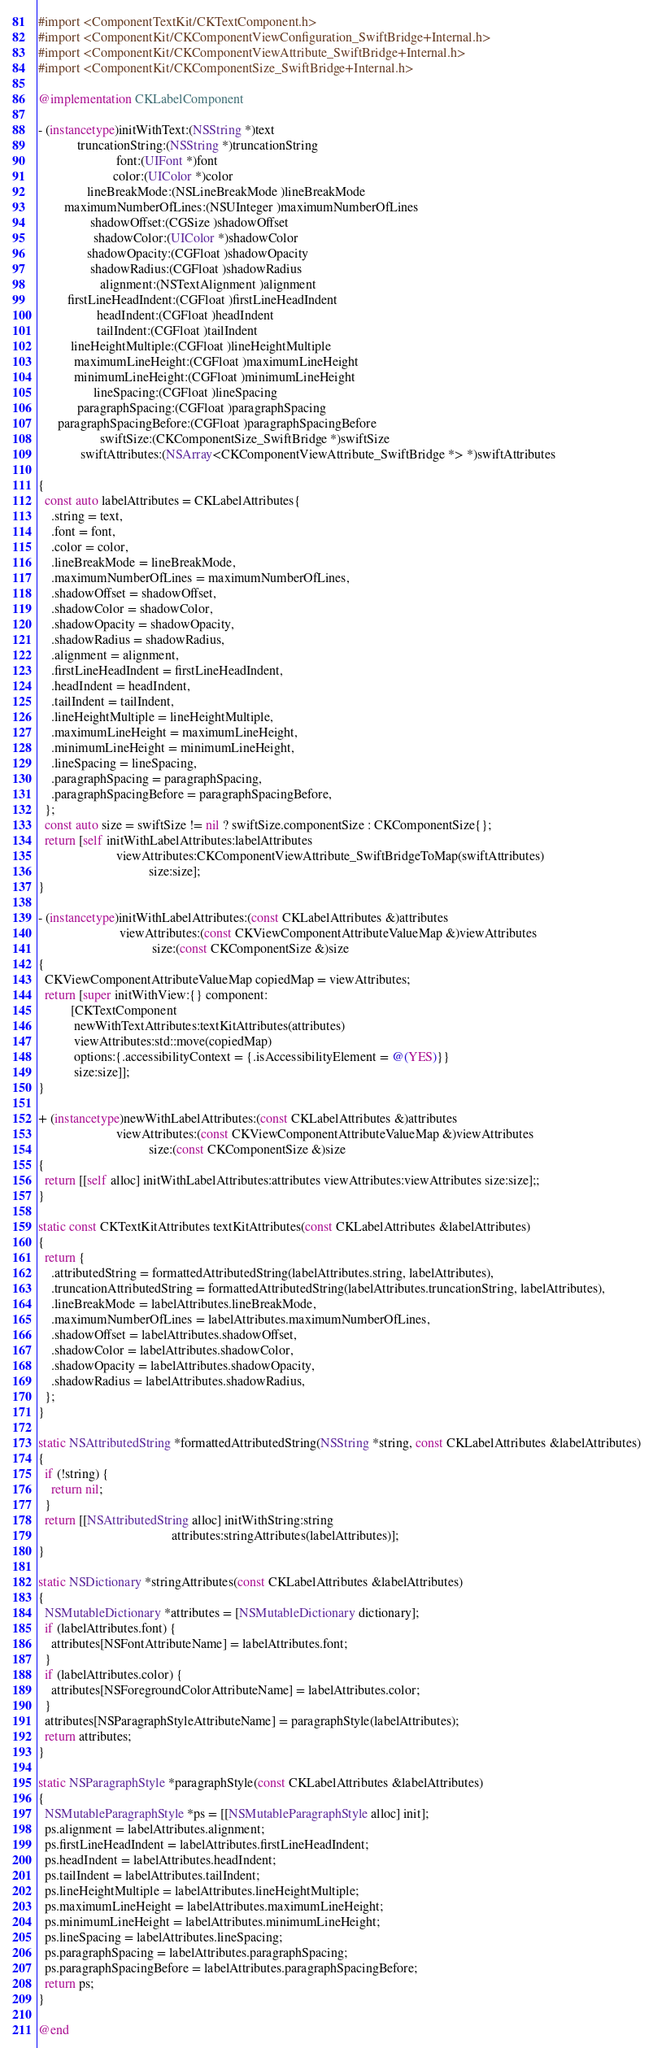Convert code to text. <code><loc_0><loc_0><loc_500><loc_500><_ObjectiveC_>#import <ComponentTextKit/CKTextComponent.h>
#import <ComponentKit/CKComponentViewConfiguration_SwiftBridge+Internal.h>
#import <ComponentKit/CKComponentViewAttribute_SwiftBridge+Internal.h>
#import <ComponentKit/CKComponentSize_SwiftBridge+Internal.h>

@implementation CKLabelComponent

- (instancetype)initWithText:(NSString *)text
            truncationString:(NSString *)truncationString
                        font:(UIFont *)font
                       color:(UIColor *)color
               lineBreakMode:(NSLineBreakMode )lineBreakMode
        maximumNumberOfLines:(NSUInteger )maximumNumberOfLines
                shadowOffset:(CGSize )shadowOffset
                 shadowColor:(UIColor *)shadowColor
               shadowOpacity:(CGFloat )shadowOpacity
                shadowRadius:(CGFloat )shadowRadius
                   alignment:(NSTextAlignment )alignment
         firstLineHeadIndent:(CGFloat )firstLineHeadIndent
                  headIndent:(CGFloat )headIndent
                  tailIndent:(CGFloat )tailIndent
          lineHeightMultiple:(CGFloat )lineHeightMultiple
           maximumLineHeight:(CGFloat )maximumLineHeight
           minimumLineHeight:(CGFloat )minimumLineHeight
                 lineSpacing:(CGFloat )lineSpacing
            paragraphSpacing:(CGFloat )paragraphSpacing
      paragraphSpacingBefore:(CGFloat )paragraphSpacingBefore
                   swiftSize:(CKComponentSize_SwiftBridge *)swiftSize
             swiftAttributes:(NSArray<CKComponentViewAttribute_SwiftBridge *> *)swiftAttributes

{
  const auto labelAttributes = CKLabelAttributes{
    .string = text,
    .font = font,
    .color = color,
    .lineBreakMode = lineBreakMode,
    .maximumNumberOfLines = maximumNumberOfLines,
    .shadowOffset = shadowOffset,
    .shadowColor = shadowColor,
    .shadowOpacity = shadowOpacity,
    .shadowRadius = shadowRadius,
    .alignment = alignment,
    .firstLineHeadIndent = firstLineHeadIndent,
    .headIndent = headIndent,
    .tailIndent = tailIndent,
    .lineHeightMultiple = lineHeightMultiple,
    .maximumLineHeight = maximumLineHeight,
    .minimumLineHeight = minimumLineHeight,
    .lineSpacing = lineSpacing,
    .paragraphSpacing = paragraphSpacing,
    .paragraphSpacingBefore = paragraphSpacingBefore,
  };
  const auto size = swiftSize != nil ? swiftSize.componentSize : CKComponentSize{};
  return [self initWithLabelAttributes:labelAttributes
                        viewAttributes:CKComponentViewAttribute_SwiftBridgeToMap(swiftAttributes)
                                  size:size];
}

- (instancetype)initWithLabelAttributes:(const CKLabelAttributes &)attributes
                         viewAttributes:(const CKViewComponentAttributeValueMap &)viewAttributes
                                   size:(const CKComponentSize &)size
{
  CKViewComponentAttributeValueMap copiedMap = viewAttributes;
  return [super initWithView:{} component:
          [CKTextComponent
           newWithTextAttributes:textKitAttributes(attributes)
           viewAttributes:std::move(copiedMap)
           options:{.accessibilityContext = {.isAccessibilityElement = @(YES)}}
           size:size]];
}

+ (instancetype)newWithLabelAttributes:(const CKLabelAttributes &)attributes
                        viewAttributes:(const CKViewComponentAttributeValueMap &)viewAttributes
                                  size:(const CKComponentSize &)size
{
  return [[self alloc] initWithLabelAttributes:attributes viewAttributes:viewAttributes size:size];;
}

static const CKTextKitAttributes textKitAttributes(const CKLabelAttributes &labelAttributes)
{
  return {
    .attributedString = formattedAttributedString(labelAttributes.string, labelAttributes),
    .truncationAttributedString = formattedAttributedString(labelAttributes.truncationString, labelAttributes),
    .lineBreakMode = labelAttributes.lineBreakMode,
    .maximumNumberOfLines = labelAttributes.maximumNumberOfLines,
    .shadowOffset = labelAttributes.shadowOffset,
    .shadowColor = labelAttributes.shadowColor,
    .shadowOpacity = labelAttributes.shadowOpacity,
    .shadowRadius = labelAttributes.shadowRadius,
  };
}

static NSAttributedString *formattedAttributedString(NSString *string, const CKLabelAttributes &labelAttributes)
{
  if (!string) {
    return nil;
  }
  return [[NSAttributedString alloc] initWithString:string
                                         attributes:stringAttributes(labelAttributes)];
}

static NSDictionary *stringAttributes(const CKLabelAttributes &labelAttributes)
{
  NSMutableDictionary *attributes = [NSMutableDictionary dictionary];
  if (labelAttributes.font) {
    attributes[NSFontAttributeName] = labelAttributes.font;
  }
  if (labelAttributes.color) {
    attributes[NSForegroundColorAttributeName] = labelAttributes.color;
  }
  attributes[NSParagraphStyleAttributeName] = paragraphStyle(labelAttributes);
  return attributes;
}

static NSParagraphStyle *paragraphStyle(const CKLabelAttributes &labelAttributes)
{
  NSMutableParagraphStyle *ps = [[NSMutableParagraphStyle alloc] init];
  ps.alignment = labelAttributes.alignment;
  ps.firstLineHeadIndent = labelAttributes.firstLineHeadIndent;
  ps.headIndent = labelAttributes.headIndent;
  ps.tailIndent = labelAttributes.tailIndent;
  ps.lineHeightMultiple = labelAttributes.lineHeightMultiple;
  ps.maximumLineHeight = labelAttributes.maximumLineHeight;
  ps.minimumLineHeight = labelAttributes.minimumLineHeight;
  ps.lineSpacing = labelAttributes.lineSpacing;
  ps.paragraphSpacing = labelAttributes.paragraphSpacing;
  ps.paragraphSpacingBefore = labelAttributes.paragraphSpacingBefore;
  return ps;
}

@end
</code> 